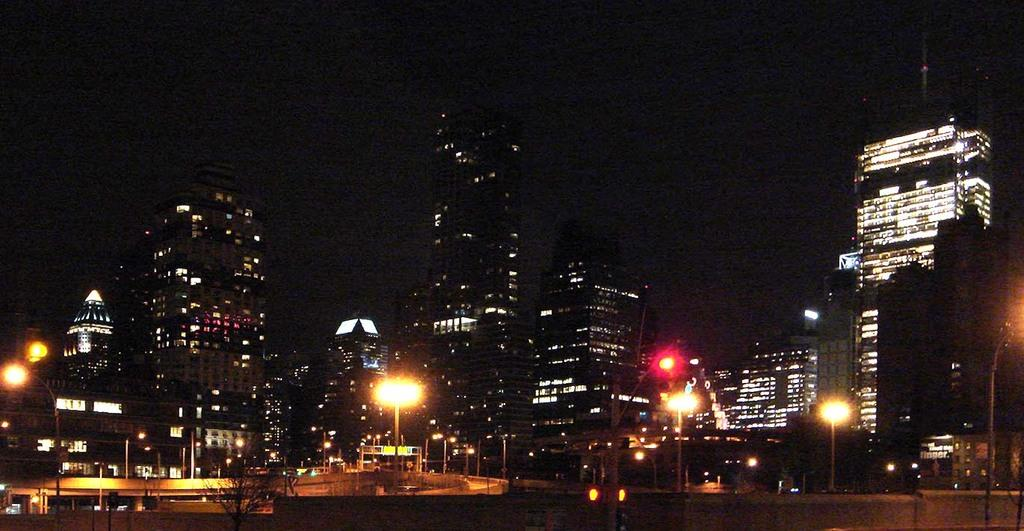What structures are located at the bottom of the image? There are poles and lights at the bottom of the image, along with trees. What can be seen behind the poles, lights, and trees? There is a bridge visible behind the poles, lights, and trees. What type of structures are in the middle of the image? There are buildings in the middle of the image. How many eyes can be seen on the giants in the image? There are no giants present in the image, so there are no eyes to count. What type of garden is visible in the image? There is no garden visible in the image; it features poles, lights, trees, a bridge, and buildings. 